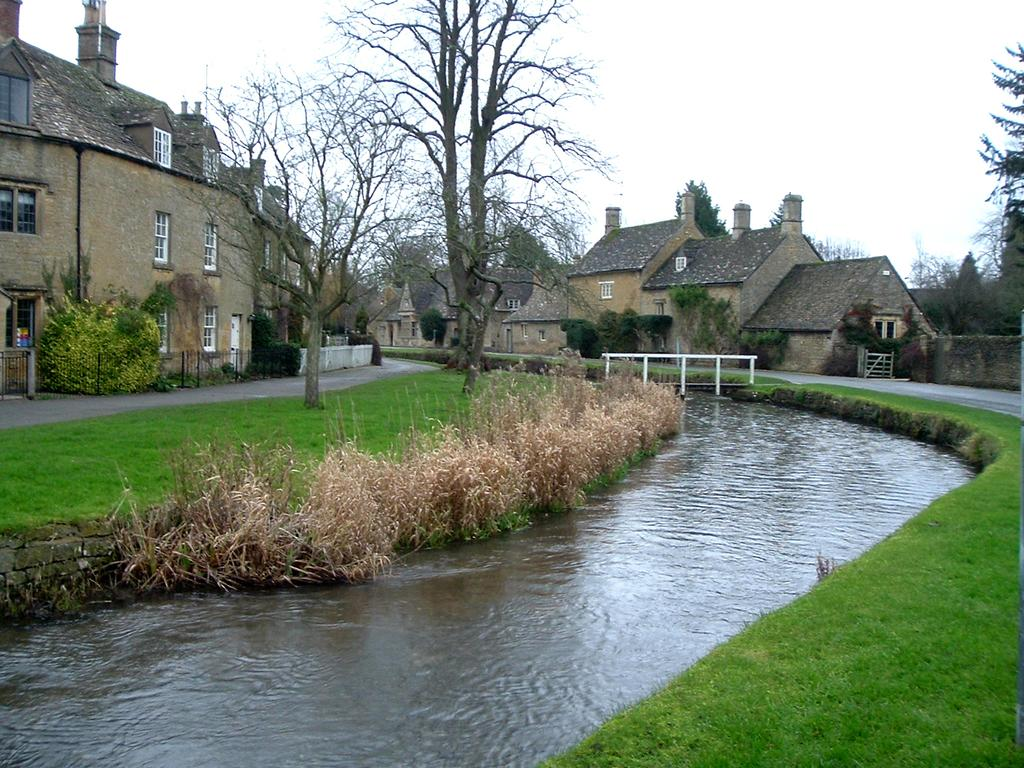What type of water feature is present in the image? There is a canal in the image. What surrounds the canal on either side? There is grass on either side of the canal. What else is located near the canal? There are roads on either side of the canal. Can you describe the structures visible in the image? There is a house on the top left side of the image, and there are houses in the background of the image. What else can be seen in the background of the image? There are trees and the sky visible in the background of the image. How many zebras can be seen grazing in the grass near the canal? There are no zebras present in the image; it features a canal with grass, roads, and houses. What type of insect is buzzing around the flowers near the trees in the background? There are no flowers or insects mentioned in the image; it only features a canal, grass, roads, houses, trees, and the sky. 